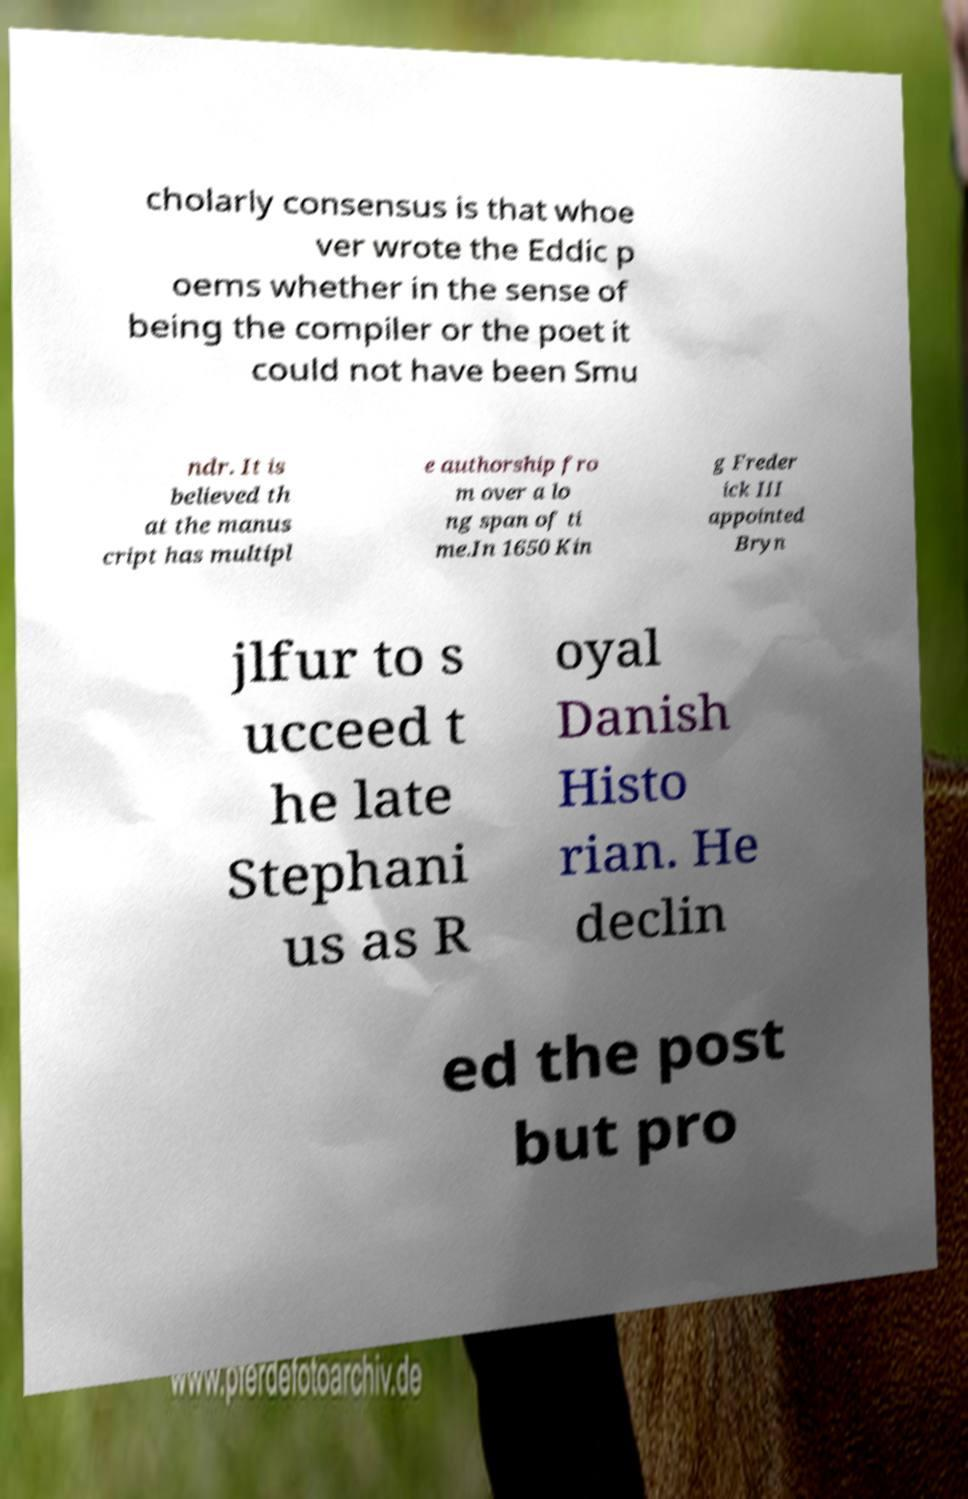There's text embedded in this image that I need extracted. Can you transcribe it verbatim? cholarly consensus is that whoe ver wrote the Eddic p oems whether in the sense of being the compiler or the poet it could not have been Smu ndr. It is believed th at the manus cript has multipl e authorship fro m over a lo ng span of ti me.In 1650 Kin g Freder ick III appointed Bryn jlfur to s ucceed t he late Stephani us as R oyal Danish Histo rian. He declin ed the post but pro 